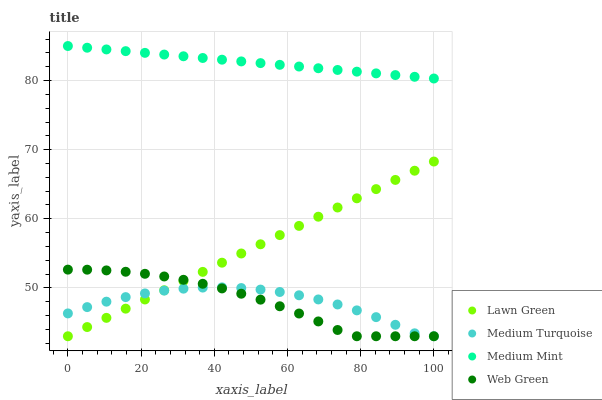Does Medium Turquoise have the minimum area under the curve?
Answer yes or no. Yes. Does Medium Mint have the maximum area under the curve?
Answer yes or no. Yes. Does Lawn Green have the minimum area under the curve?
Answer yes or no. No. Does Lawn Green have the maximum area under the curve?
Answer yes or no. No. Is Medium Mint the smoothest?
Answer yes or no. Yes. Is Medium Turquoise the roughest?
Answer yes or no. Yes. Is Lawn Green the smoothest?
Answer yes or no. No. Is Lawn Green the roughest?
Answer yes or no. No. Does Lawn Green have the lowest value?
Answer yes or no. Yes. Does Medium Mint have the highest value?
Answer yes or no. Yes. Does Lawn Green have the highest value?
Answer yes or no. No. Is Lawn Green less than Medium Mint?
Answer yes or no. Yes. Is Medium Mint greater than Lawn Green?
Answer yes or no. Yes. Does Web Green intersect Medium Turquoise?
Answer yes or no. Yes. Is Web Green less than Medium Turquoise?
Answer yes or no. No. Is Web Green greater than Medium Turquoise?
Answer yes or no. No. Does Lawn Green intersect Medium Mint?
Answer yes or no. No. 